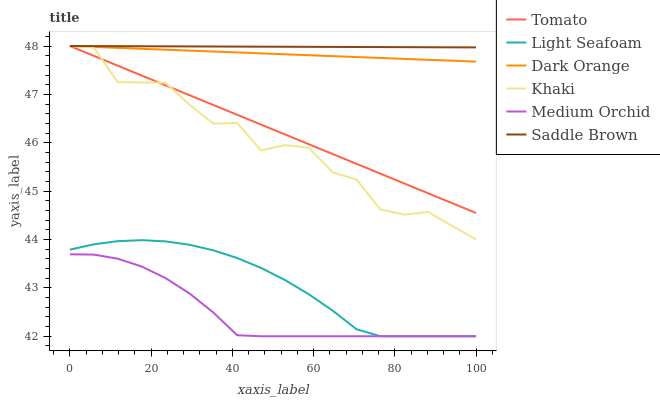Does Medium Orchid have the minimum area under the curve?
Answer yes or no. Yes. Does Saddle Brown have the maximum area under the curve?
Answer yes or no. Yes. Does Dark Orange have the minimum area under the curve?
Answer yes or no. No. Does Dark Orange have the maximum area under the curve?
Answer yes or no. No. Is Saddle Brown the smoothest?
Answer yes or no. Yes. Is Khaki the roughest?
Answer yes or no. Yes. Is Dark Orange the smoothest?
Answer yes or no. No. Is Dark Orange the roughest?
Answer yes or no. No. Does Dark Orange have the lowest value?
Answer yes or no. No. Does Saddle Brown have the highest value?
Answer yes or no. Yes. Does Medium Orchid have the highest value?
Answer yes or no. No. Is Light Seafoam less than Saddle Brown?
Answer yes or no. Yes. Is Tomato greater than Medium Orchid?
Answer yes or no. Yes. Does Medium Orchid intersect Light Seafoam?
Answer yes or no. Yes. Is Medium Orchid less than Light Seafoam?
Answer yes or no. No. Is Medium Orchid greater than Light Seafoam?
Answer yes or no. No. Does Light Seafoam intersect Saddle Brown?
Answer yes or no. No. 